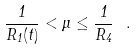<formula> <loc_0><loc_0><loc_500><loc_500>\frac { 1 } { R _ { 1 } ( t ) } < \mu \leq \frac { 1 } { R _ { 4 } } \ .</formula> 